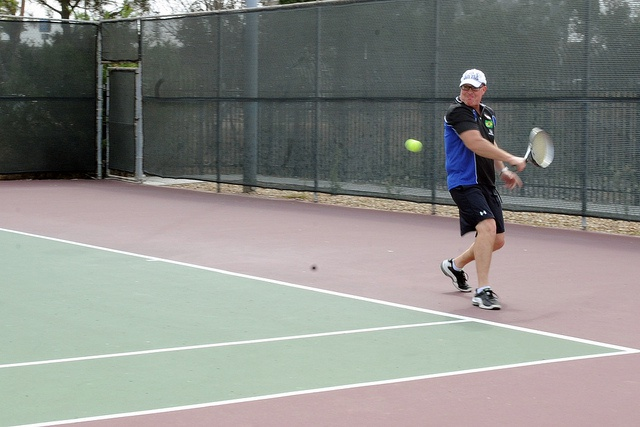Describe the objects in this image and their specific colors. I can see people in darkgreen, black, brown, darkgray, and tan tones, tennis racket in darkgreen, darkgray, gray, and lightgray tones, and sports ball in darkgreen, lightgreen, olive, and khaki tones in this image. 